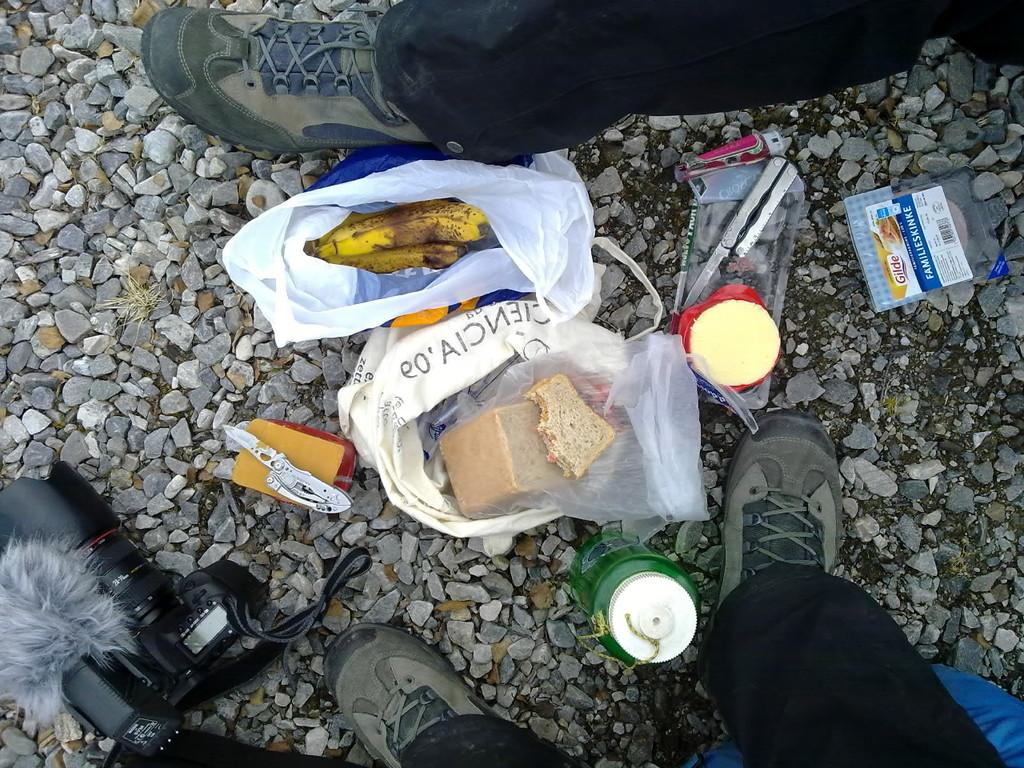What is at the bottom of the image? There are stones at the bottom of the image. What else can be seen in the image besides the stones? There are legs of persons, a tin, bananas, a knife, breads, a cover, and a digital camera visible in the image. What might be used for cutting in the image? There is a knife in the image. What type of fruit is present in the image? There are bananas inas in the image. What type of map can be seen in the image? There is no map present in the image. What type of ghost is visible in the image? There are no ghosts present in the image. 